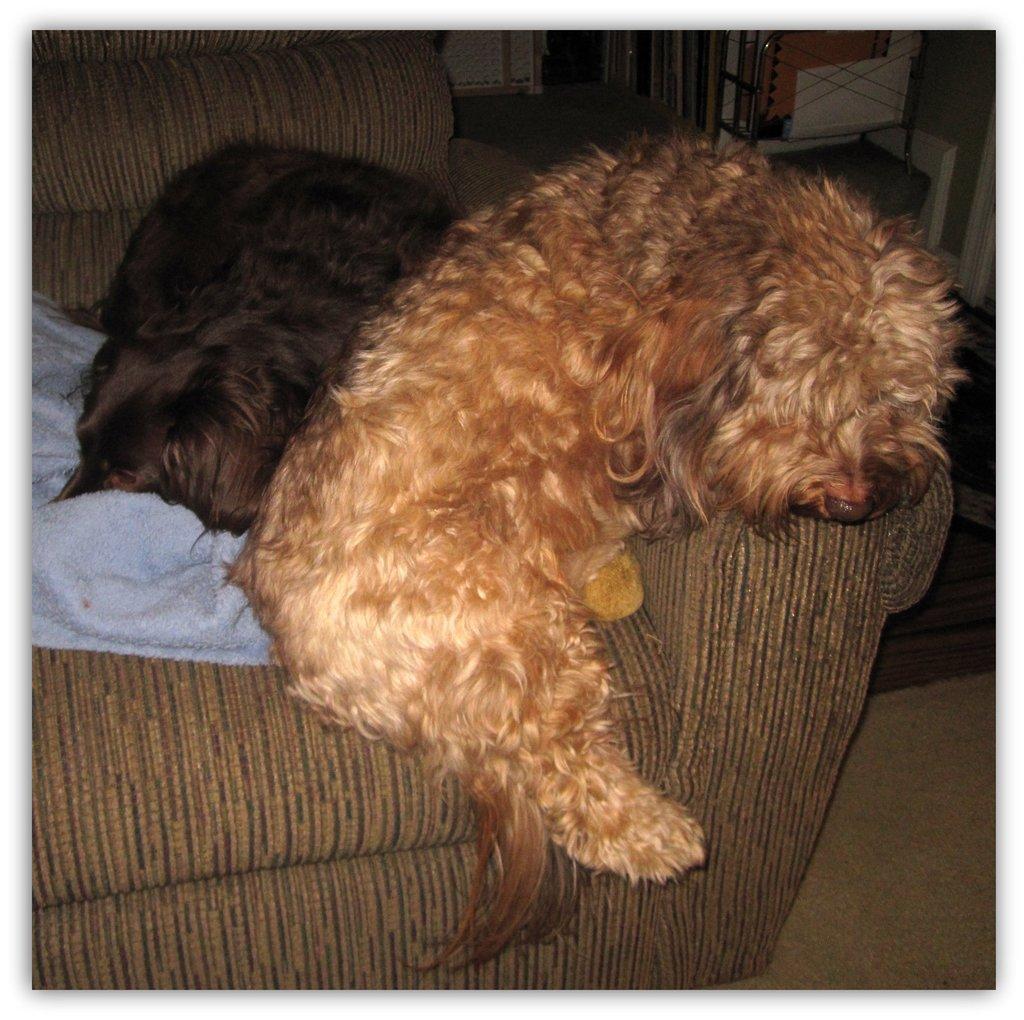Could you give a brief overview of what you see in this image? In this picture we can see there are two dogs lying on the couch and on the couch there is a cloth. At the top right corner of the image, there are some objects. 